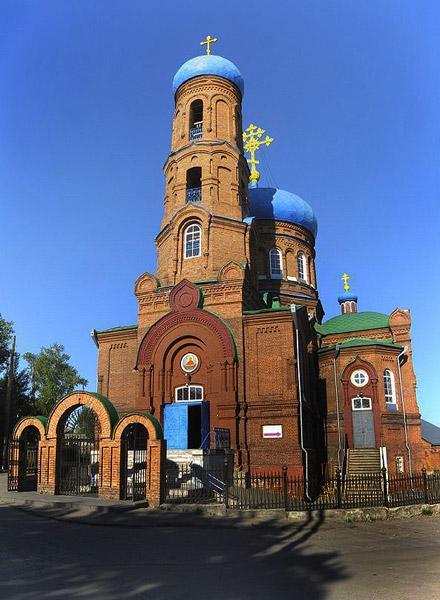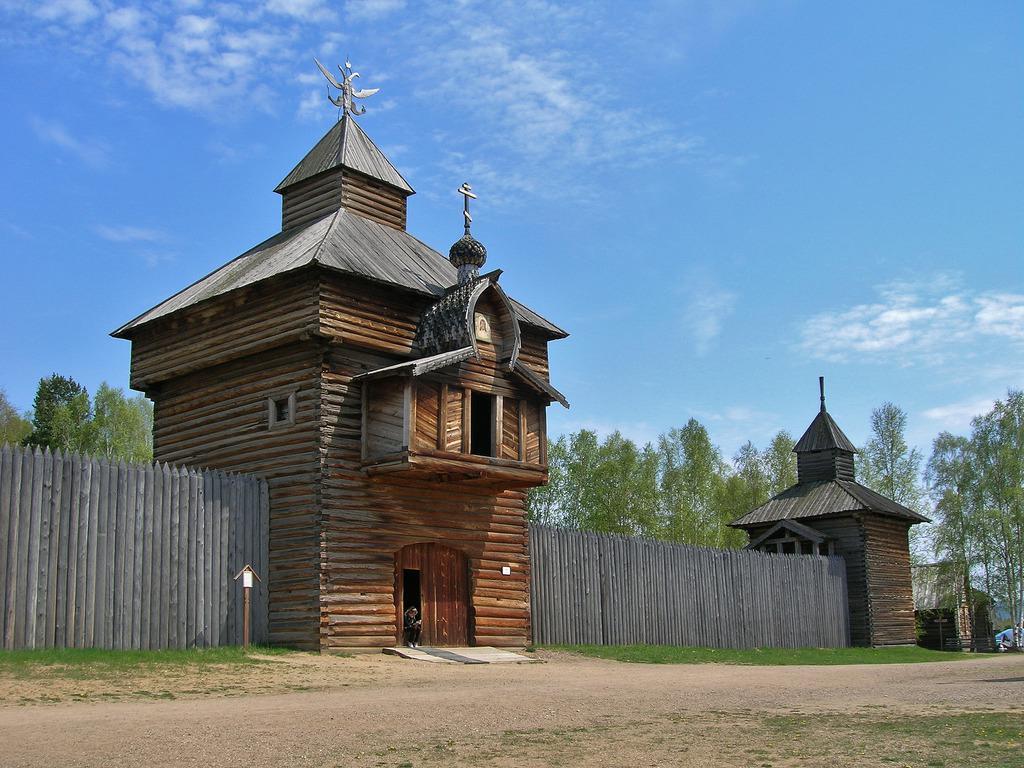The first image is the image on the left, the second image is the image on the right. Considering the images on both sides, is "In one image, the roof features green shapes topped with crosses." valid? Answer yes or no. No. The first image is the image on the left, the second image is the image on the right. Given the left and right images, does the statement "There is a cross atop the building in the image on the left." hold true? Answer yes or no. Yes. 